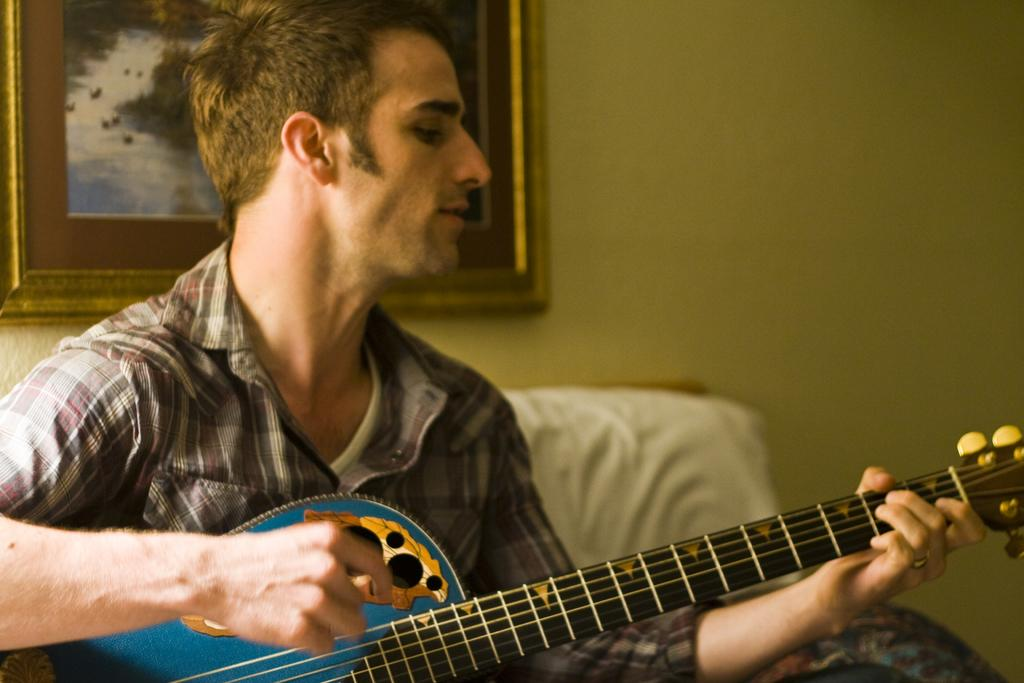Who is the main subject in the image? There is a person in the image. What is the person wearing? The person is wearing a shirt. What activity is the person engaged in? The person is playing a guitar. How many beds are visible in the image? There are no beds visible in the image; it features a person playing a guitar. What statement does the person in the image make? The image does not include any text or dialogue, so it is not possible to determine what statement the person might make. 